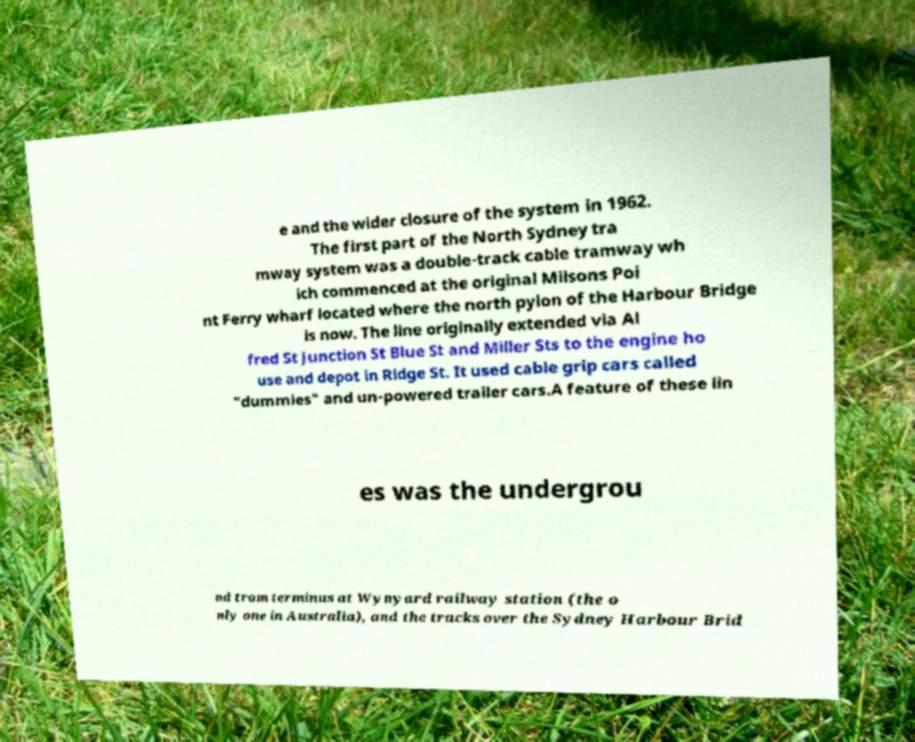Could you assist in decoding the text presented in this image and type it out clearly? e and the wider closure of the system in 1962. The first part of the North Sydney tra mway system was a double-track cable tramway wh ich commenced at the original Milsons Poi nt Ferry wharf located where the north pylon of the Harbour Bridge is now. The line originally extended via Al fred St Junction St Blue St and Miller Sts to the engine ho use and depot in Ridge St. It used cable grip cars called "dummies" and un-powered trailer cars.A feature of these lin es was the undergrou nd tram terminus at Wynyard railway station (the o nly one in Australia), and the tracks over the Sydney Harbour Brid 